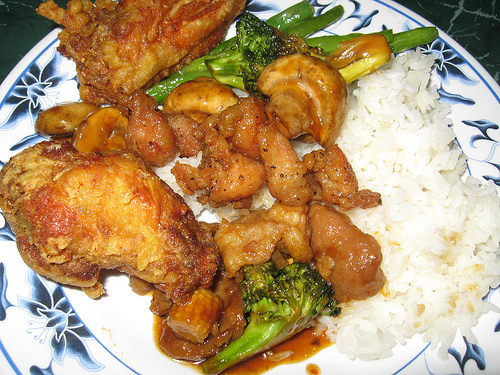<image>
Is the broccoli next to the chicken? Yes. The broccoli is positioned adjacent to the chicken, located nearby in the same general area. Where is the food in relation to the table? Is it on the table? Yes. Looking at the image, I can see the food is positioned on top of the table, with the table providing support. 